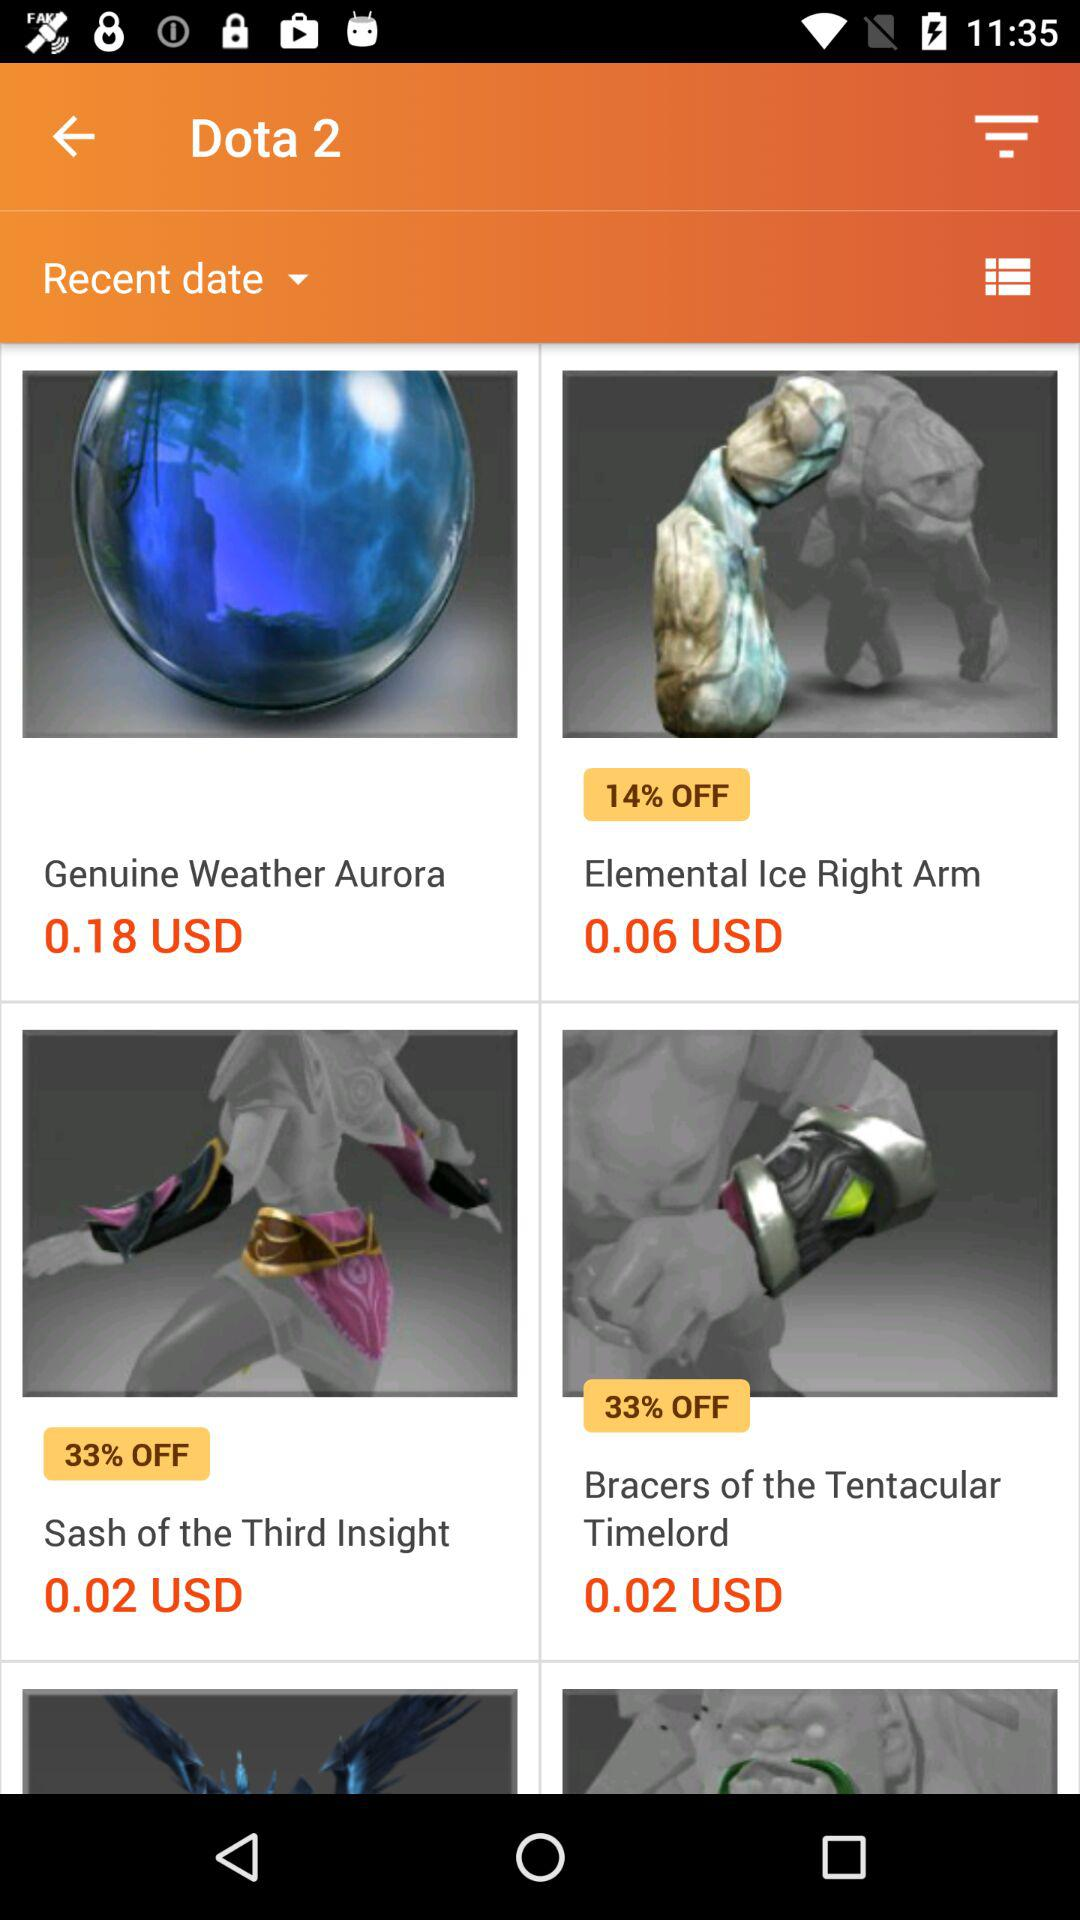How much of a percentage off is applicable for the "Bracers of the Tentacular Timelord"? For the "Bracers of the Tentacular Timelord", 33% off is applicable. 